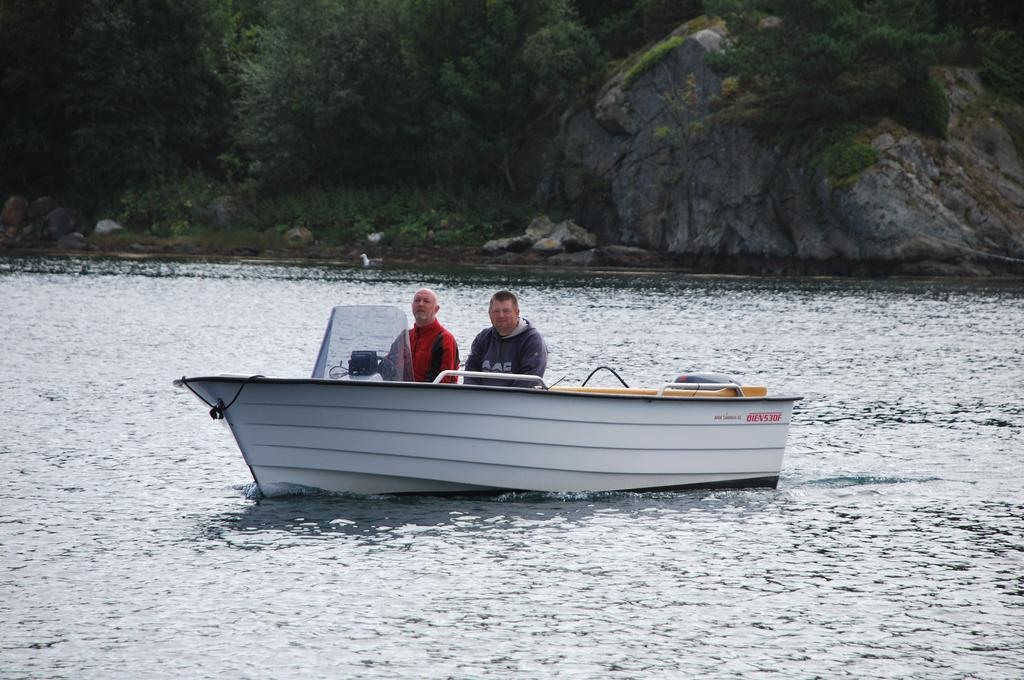What is the main subject in the center of the image? There is a boat in the center of the image. Where is the boat located? The boat is in the water. How many people are in the boat? There are two people in the boat. What can be seen in the background of the image? There are rocks and trees in the background of the image. What type of science experiment is being conducted on the boat in the image? There is no indication of a science experiment being conducted on the boat in the image. Can you see a chain connecting the boat to the rocks in the image? There is no chain visible in the image, and the boat is not connected to the rocks. 